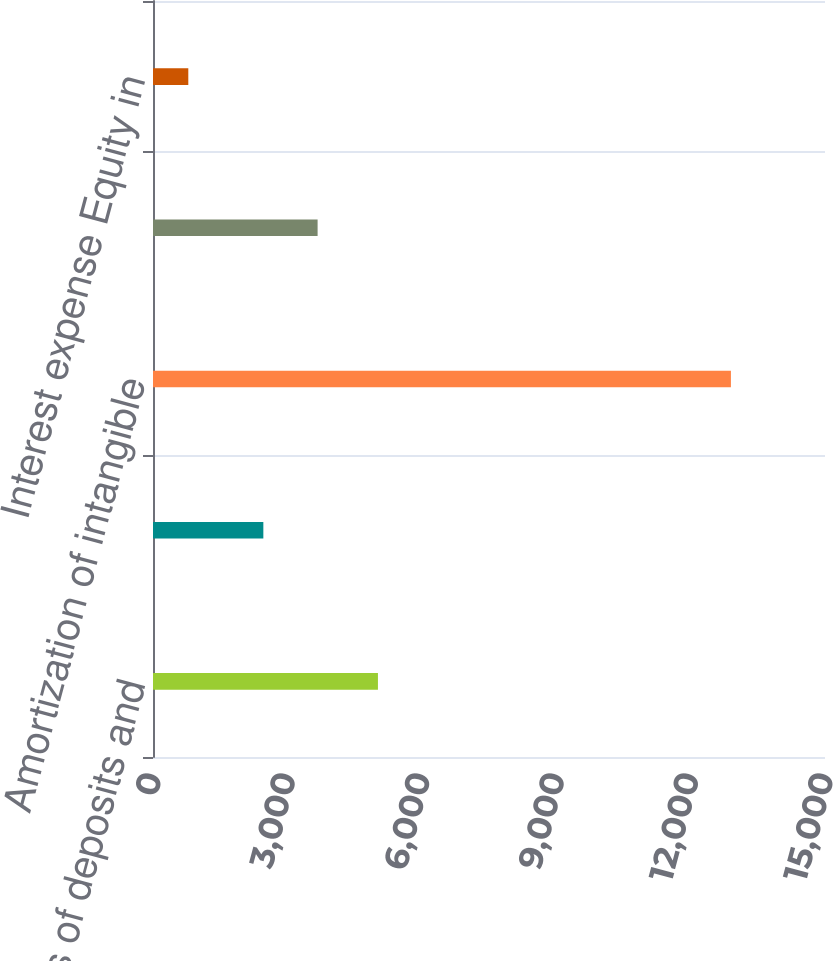Convert chart to OTSL. <chart><loc_0><loc_0><loc_500><loc_500><bar_chart><fcel>Write-offs of deposits and<fcel>Lease exit and related costs<fcel>Amortization of intangible<fcel>Interest income<fcel>Interest expense Equity in<nl><fcel>5021<fcel>2463<fcel>12900<fcel>3674.2<fcel>788<nl></chart> 